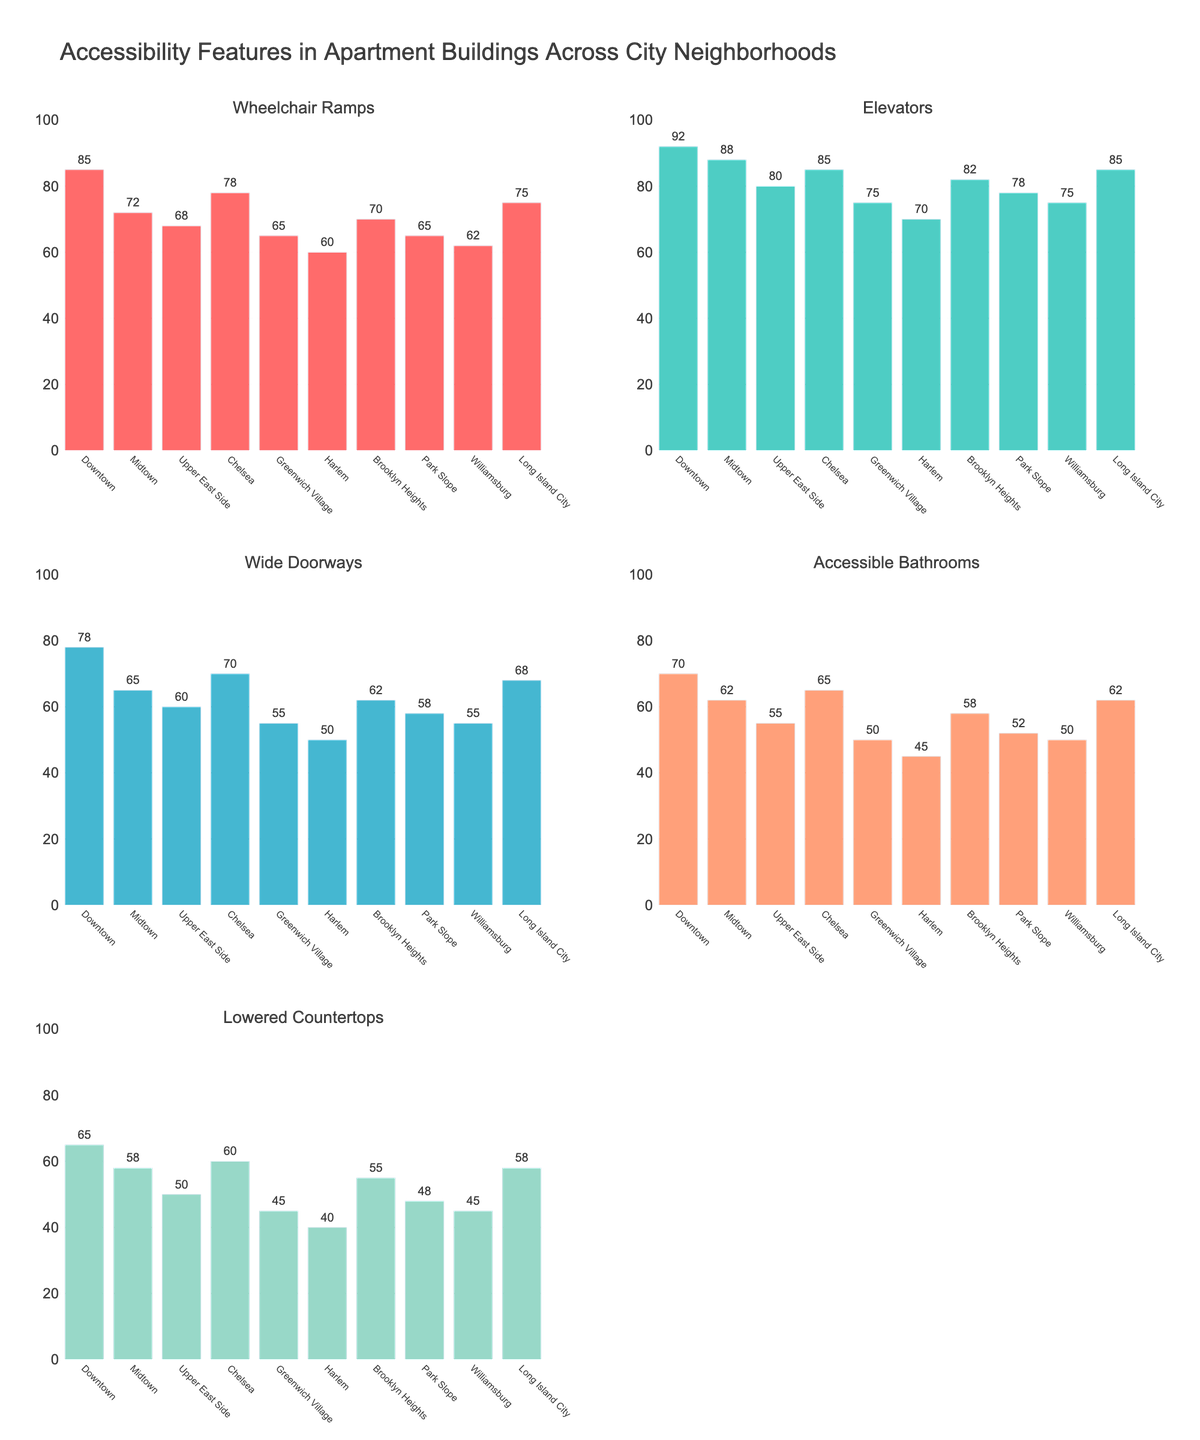What's the title of the figure? The title is typically at the top of the figure and is intended to provide an overview of what the figure is about. In this case, the title is "Accessibility Features in Apartment Buildings Across City Neighborhoods".
Answer: Accessibility Features in Apartment Buildings Across City Neighborhoods Which neighborhood has the maximum number of wheelchair ramps? To find this, look at the bar in the subplot for Wheelchair Ramps that reaches the highest value on the y-axis.
Answer: Downtown How many neighborhoods have more than 70 elevators? Check each bar in the Elevators subplot to see if it exceeds 70 and count those that do. The neighborhoods are Downtown, Midtown, Chelsea, Brooklyn Heights, Long Island City.
Answer: 5 What is the difference in the number of accessible bathrooms between Downtown and Harlem? Find the values for Accessible Bathrooms for both Downtown (70) and Harlem (45) and subtract the smaller value from the larger value. 70 - 45 = 25
Answer: 25 Which neighborhood features the least number of wide doorways? Identify the shortest bar in the subplot for Wide Doorways. The smallest value corresponds to Harlem with 50 wide doorways.
Answer: Harlem What is the average number of lowered countertops across all neighborhoods? Sum up the values of Lowered Countertops for all neighborhoods and divide by the number of neighborhoods: (65 + 58 + 50 + 60 + 45 + 40 + 55 + 48 + 45 + 58)/10.
Answer: 52.4 Compare Midtown and Park Slope in terms of the number of elevators and identify which neighborhood has more. Compare the elevator counts of Midtown (88) and Park Slope (78), noting that Midtown has more.
Answer: Midtown Which neighborhood has the most consistent (narrowest range) number of accessibility features across all categories? Calculate the range (max-min) of each neighborhood's values across all categories. The smallest range points to the most consistent neighborhood. Calculate for each neighborhood. For Downtown: Maximum (92) - Minimum (65) = 27, for other neighborhoods, similarly calculate. Downtown has the smallest range of 27.
Answer: Downtown What is the total number of wheelchair ramps and elevators in Chelsea? Add the number of Wheelchair Ramps (78) and Elevators (85) in Chelsea: 78 + 85 = 163.
Answer: 163 What are the values for accessible bathrooms in the neighborhoods with the 3 highest counts of Wide Doorways? First identify the top 3 neighborhoods for Wide Doorways: Downtown (78), Chelsea (70), and Brooklyn Heights (62). Then check the Accessible Bathrooms for these neighborhoods: Downtown (70), Chelsea (65), Brooklyn Heights (58).
Answer: 70, 65, 58 